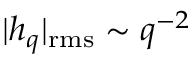Convert formula to latex. <formula><loc_0><loc_0><loc_500><loc_500>| h _ { q } | _ { r m s } \sim q ^ { - 2 }</formula> 